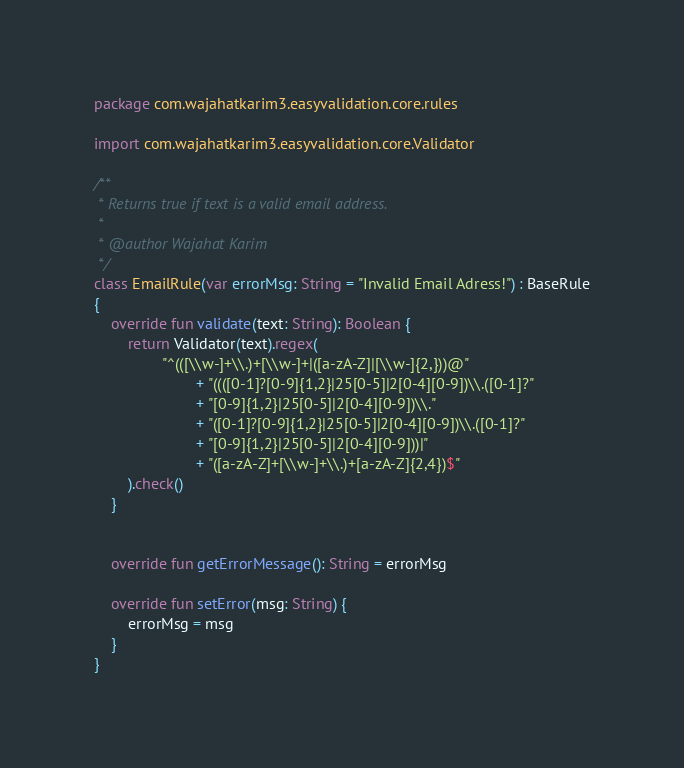Convert code to text. <code><loc_0><loc_0><loc_500><loc_500><_Kotlin_>package com.wajahatkarim3.easyvalidation.core.rules

import com.wajahatkarim3.easyvalidation.core.Validator

/**
 * Returns true if text is a valid email address.
 *
 * @author Wajahat Karim
 */
class EmailRule(var errorMsg: String = "Invalid Email Adress!") : BaseRule
{
    override fun validate(text: String): Boolean {
        return Validator(text).regex(
                "^(([\\w-]+\\.)+[\\w-]+|([a-zA-Z]|[\\w-]{2,}))@"
                        + "((([0-1]?[0-9]{1,2}|25[0-5]|2[0-4][0-9])\\.([0-1]?"
                        + "[0-9]{1,2}|25[0-5]|2[0-4][0-9])\\."
                        + "([0-1]?[0-9]{1,2}|25[0-5]|2[0-4][0-9])\\.([0-1]?"
                        + "[0-9]{1,2}|25[0-5]|2[0-4][0-9]))|"
                        + "([a-zA-Z]+[\\w-]+\\.)+[a-zA-Z]{2,4})$"
        ).check()
    }


    override fun getErrorMessage(): String = errorMsg

    override fun setError(msg: String) {
        errorMsg = msg
    }
}</code> 